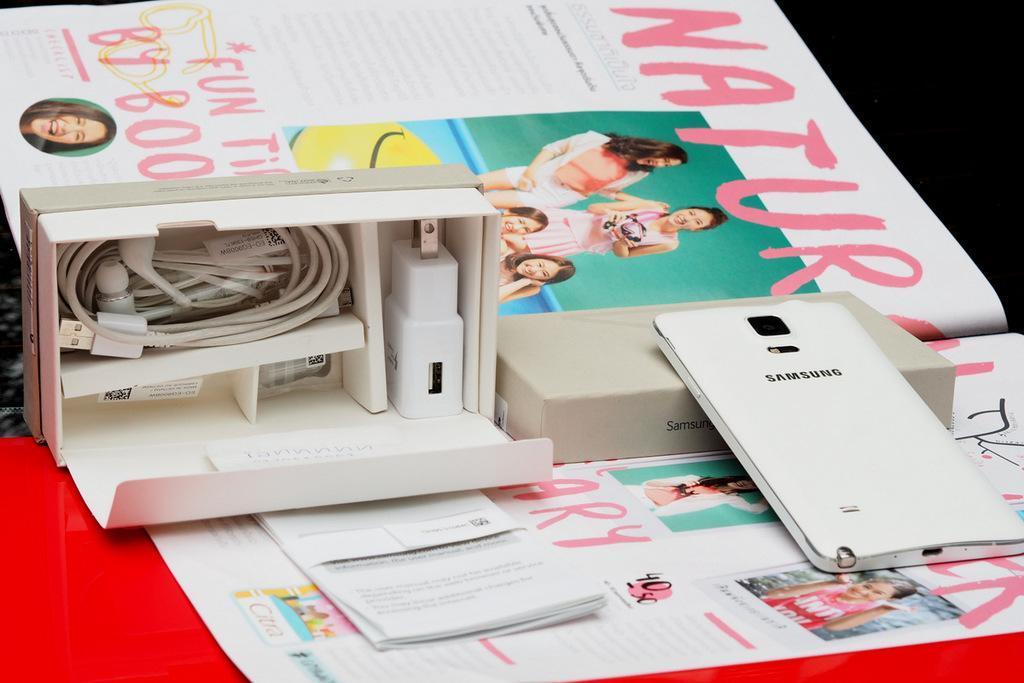How would you summarize this image in a sentence or two? In this image I can see a mobile. There is a mobile box with adaptor, earphones and a charging cable in it. Also there are papers on an object. 